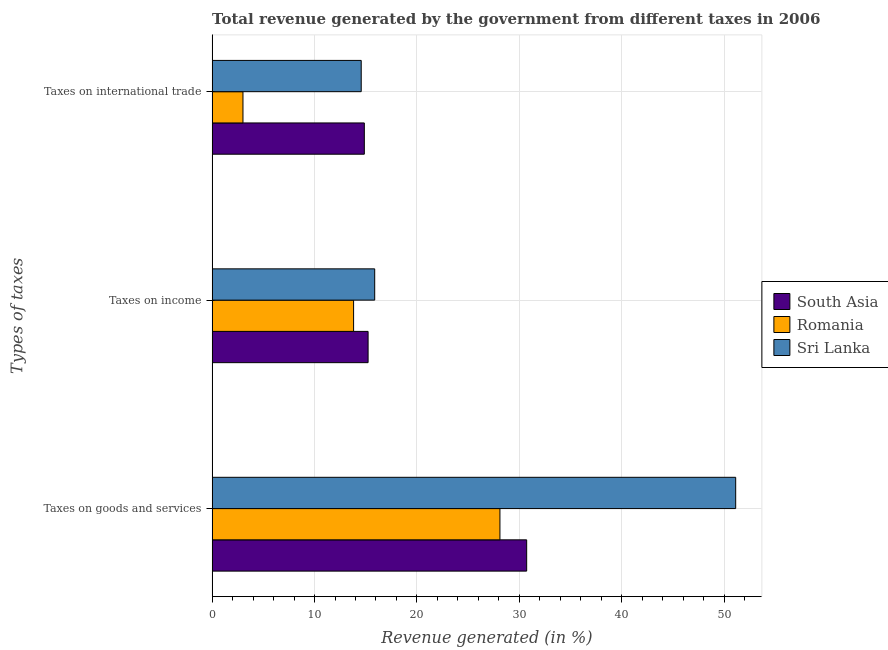How many different coloured bars are there?
Give a very brief answer. 3. Are the number of bars on each tick of the Y-axis equal?
Ensure brevity in your answer.  Yes. How many bars are there on the 3rd tick from the top?
Your response must be concise. 3. How many bars are there on the 1st tick from the bottom?
Make the answer very short. 3. What is the label of the 1st group of bars from the top?
Ensure brevity in your answer.  Taxes on international trade. What is the percentage of revenue generated by taxes on goods and services in Romania?
Keep it short and to the point. 28.11. Across all countries, what is the maximum percentage of revenue generated by taxes on goods and services?
Your response must be concise. 51.13. Across all countries, what is the minimum percentage of revenue generated by taxes on income?
Your answer should be compact. 13.82. In which country was the percentage of revenue generated by tax on international trade maximum?
Offer a very short reply. South Asia. In which country was the percentage of revenue generated by tax on international trade minimum?
Offer a terse response. Romania. What is the total percentage of revenue generated by taxes on income in the graph?
Ensure brevity in your answer.  44.93. What is the difference between the percentage of revenue generated by tax on international trade in Sri Lanka and that in Romania?
Your answer should be very brief. 11.55. What is the difference between the percentage of revenue generated by tax on international trade in Sri Lanka and the percentage of revenue generated by taxes on goods and services in Romania?
Your answer should be very brief. -13.55. What is the average percentage of revenue generated by taxes on goods and services per country?
Your answer should be very brief. 36.65. What is the difference between the percentage of revenue generated by taxes on income and percentage of revenue generated by taxes on goods and services in Sri Lanka?
Keep it short and to the point. -35.25. What is the ratio of the percentage of revenue generated by taxes on goods and services in Romania to that in Sri Lanka?
Provide a succinct answer. 0.55. Is the percentage of revenue generated by taxes on goods and services in South Asia less than that in Romania?
Offer a terse response. No. Is the difference between the percentage of revenue generated by taxes on goods and services in Sri Lanka and South Asia greater than the difference between the percentage of revenue generated by tax on international trade in Sri Lanka and South Asia?
Ensure brevity in your answer.  Yes. What is the difference between the highest and the second highest percentage of revenue generated by taxes on goods and services?
Your response must be concise. 20.41. What is the difference between the highest and the lowest percentage of revenue generated by taxes on income?
Provide a succinct answer. 2.06. In how many countries, is the percentage of revenue generated by taxes on goods and services greater than the average percentage of revenue generated by taxes on goods and services taken over all countries?
Keep it short and to the point. 1. Is the sum of the percentage of revenue generated by taxes on goods and services in Sri Lanka and Romania greater than the maximum percentage of revenue generated by tax on international trade across all countries?
Offer a very short reply. Yes. What does the 3rd bar from the bottom in Taxes on international trade represents?
Offer a very short reply. Sri Lanka. How many countries are there in the graph?
Ensure brevity in your answer.  3. How are the legend labels stacked?
Provide a succinct answer. Vertical. What is the title of the graph?
Ensure brevity in your answer.  Total revenue generated by the government from different taxes in 2006. Does "Mauritania" appear as one of the legend labels in the graph?
Give a very brief answer. No. What is the label or title of the X-axis?
Offer a very short reply. Revenue generated (in %). What is the label or title of the Y-axis?
Your answer should be very brief. Types of taxes. What is the Revenue generated (in %) of South Asia in Taxes on goods and services?
Offer a terse response. 30.72. What is the Revenue generated (in %) of Romania in Taxes on goods and services?
Keep it short and to the point. 28.11. What is the Revenue generated (in %) of Sri Lanka in Taxes on goods and services?
Offer a very short reply. 51.13. What is the Revenue generated (in %) of South Asia in Taxes on income?
Ensure brevity in your answer.  15.23. What is the Revenue generated (in %) of Romania in Taxes on income?
Provide a short and direct response. 13.82. What is the Revenue generated (in %) in Sri Lanka in Taxes on income?
Offer a terse response. 15.88. What is the Revenue generated (in %) of South Asia in Taxes on international trade?
Offer a terse response. 14.86. What is the Revenue generated (in %) in Romania in Taxes on international trade?
Offer a very short reply. 3.01. What is the Revenue generated (in %) in Sri Lanka in Taxes on international trade?
Make the answer very short. 14.56. Across all Types of taxes, what is the maximum Revenue generated (in %) in South Asia?
Ensure brevity in your answer.  30.72. Across all Types of taxes, what is the maximum Revenue generated (in %) in Romania?
Your answer should be very brief. 28.11. Across all Types of taxes, what is the maximum Revenue generated (in %) in Sri Lanka?
Offer a terse response. 51.13. Across all Types of taxes, what is the minimum Revenue generated (in %) in South Asia?
Offer a terse response. 14.86. Across all Types of taxes, what is the minimum Revenue generated (in %) in Romania?
Make the answer very short. 3.01. Across all Types of taxes, what is the minimum Revenue generated (in %) of Sri Lanka?
Keep it short and to the point. 14.56. What is the total Revenue generated (in %) in South Asia in the graph?
Your answer should be very brief. 60.82. What is the total Revenue generated (in %) in Romania in the graph?
Your answer should be compact. 44.94. What is the total Revenue generated (in %) of Sri Lanka in the graph?
Provide a short and direct response. 81.57. What is the difference between the Revenue generated (in %) in South Asia in Taxes on goods and services and that in Taxes on income?
Your answer should be very brief. 15.49. What is the difference between the Revenue generated (in %) of Romania in Taxes on goods and services and that in Taxes on income?
Make the answer very short. 14.29. What is the difference between the Revenue generated (in %) of Sri Lanka in Taxes on goods and services and that in Taxes on income?
Keep it short and to the point. 35.25. What is the difference between the Revenue generated (in %) in South Asia in Taxes on goods and services and that in Taxes on international trade?
Ensure brevity in your answer.  15.85. What is the difference between the Revenue generated (in %) of Romania in Taxes on goods and services and that in Taxes on international trade?
Your response must be concise. 25.1. What is the difference between the Revenue generated (in %) of Sri Lanka in Taxes on goods and services and that in Taxes on international trade?
Ensure brevity in your answer.  36.57. What is the difference between the Revenue generated (in %) of South Asia in Taxes on income and that in Taxes on international trade?
Keep it short and to the point. 0.37. What is the difference between the Revenue generated (in %) in Romania in Taxes on income and that in Taxes on international trade?
Give a very brief answer. 10.8. What is the difference between the Revenue generated (in %) of Sri Lanka in Taxes on income and that in Taxes on international trade?
Ensure brevity in your answer.  1.32. What is the difference between the Revenue generated (in %) in South Asia in Taxes on goods and services and the Revenue generated (in %) in Romania in Taxes on income?
Offer a terse response. 16.9. What is the difference between the Revenue generated (in %) of South Asia in Taxes on goods and services and the Revenue generated (in %) of Sri Lanka in Taxes on income?
Offer a very short reply. 14.84. What is the difference between the Revenue generated (in %) in Romania in Taxes on goods and services and the Revenue generated (in %) in Sri Lanka in Taxes on income?
Keep it short and to the point. 12.23. What is the difference between the Revenue generated (in %) of South Asia in Taxes on goods and services and the Revenue generated (in %) of Romania in Taxes on international trade?
Your answer should be very brief. 27.71. What is the difference between the Revenue generated (in %) in South Asia in Taxes on goods and services and the Revenue generated (in %) in Sri Lanka in Taxes on international trade?
Keep it short and to the point. 16.16. What is the difference between the Revenue generated (in %) of Romania in Taxes on goods and services and the Revenue generated (in %) of Sri Lanka in Taxes on international trade?
Keep it short and to the point. 13.55. What is the difference between the Revenue generated (in %) in South Asia in Taxes on income and the Revenue generated (in %) in Romania in Taxes on international trade?
Make the answer very short. 12.22. What is the difference between the Revenue generated (in %) in South Asia in Taxes on income and the Revenue generated (in %) in Sri Lanka in Taxes on international trade?
Provide a short and direct response. 0.67. What is the difference between the Revenue generated (in %) of Romania in Taxes on income and the Revenue generated (in %) of Sri Lanka in Taxes on international trade?
Your response must be concise. -0.74. What is the average Revenue generated (in %) in South Asia per Types of taxes?
Give a very brief answer. 20.27. What is the average Revenue generated (in %) in Romania per Types of taxes?
Your answer should be compact. 14.98. What is the average Revenue generated (in %) in Sri Lanka per Types of taxes?
Offer a very short reply. 27.19. What is the difference between the Revenue generated (in %) of South Asia and Revenue generated (in %) of Romania in Taxes on goods and services?
Give a very brief answer. 2.61. What is the difference between the Revenue generated (in %) in South Asia and Revenue generated (in %) in Sri Lanka in Taxes on goods and services?
Your answer should be very brief. -20.41. What is the difference between the Revenue generated (in %) in Romania and Revenue generated (in %) in Sri Lanka in Taxes on goods and services?
Offer a terse response. -23.02. What is the difference between the Revenue generated (in %) in South Asia and Revenue generated (in %) in Romania in Taxes on income?
Make the answer very short. 1.42. What is the difference between the Revenue generated (in %) in South Asia and Revenue generated (in %) in Sri Lanka in Taxes on income?
Ensure brevity in your answer.  -0.65. What is the difference between the Revenue generated (in %) in Romania and Revenue generated (in %) in Sri Lanka in Taxes on income?
Ensure brevity in your answer.  -2.06. What is the difference between the Revenue generated (in %) in South Asia and Revenue generated (in %) in Romania in Taxes on international trade?
Provide a succinct answer. 11.85. What is the difference between the Revenue generated (in %) of South Asia and Revenue generated (in %) of Sri Lanka in Taxes on international trade?
Keep it short and to the point. 0.3. What is the difference between the Revenue generated (in %) in Romania and Revenue generated (in %) in Sri Lanka in Taxes on international trade?
Make the answer very short. -11.55. What is the ratio of the Revenue generated (in %) in South Asia in Taxes on goods and services to that in Taxes on income?
Make the answer very short. 2.02. What is the ratio of the Revenue generated (in %) in Romania in Taxes on goods and services to that in Taxes on income?
Provide a succinct answer. 2.03. What is the ratio of the Revenue generated (in %) of Sri Lanka in Taxes on goods and services to that in Taxes on income?
Offer a very short reply. 3.22. What is the ratio of the Revenue generated (in %) in South Asia in Taxes on goods and services to that in Taxes on international trade?
Provide a short and direct response. 2.07. What is the ratio of the Revenue generated (in %) in Romania in Taxes on goods and services to that in Taxes on international trade?
Your answer should be compact. 9.33. What is the ratio of the Revenue generated (in %) of Sri Lanka in Taxes on goods and services to that in Taxes on international trade?
Offer a very short reply. 3.51. What is the ratio of the Revenue generated (in %) in South Asia in Taxes on income to that in Taxes on international trade?
Your response must be concise. 1.02. What is the ratio of the Revenue generated (in %) in Romania in Taxes on income to that in Taxes on international trade?
Offer a very short reply. 4.59. What is the ratio of the Revenue generated (in %) in Sri Lanka in Taxes on income to that in Taxes on international trade?
Keep it short and to the point. 1.09. What is the difference between the highest and the second highest Revenue generated (in %) in South Asia?
Offer a very short reply. 15.49. What is the difference between the highest and the second highest Revenue generated (in %) in Romania?
Provide a succinct answer. 14.29. What is the difference between the highest and the second highest Revenue generated (in %) in Sri Lanka?
Your answer should be very brief. 35.25. What is the difference between the highest and the lowest Revenue generated (in %) in South Asia?
Your answer should be very brief. 15.85. What is the difference between the highest and the lowest Revenue generated (in %) in Romania?
Your response must be concise. 25.1. What is the difference between the highest and the lowest Revenue generated (in %) in Sri Lanka?
Your answer should be very brief. 36.57. 